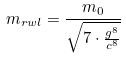<formula> <loc_0><loc_0><loc_500><loc_500>m _ { r w l } = \frac { m _ { 0 } } { \sqrt { 7 \cdot \frac { g ^ { 8 } } { c ^ { 8 } } } }</formula> 